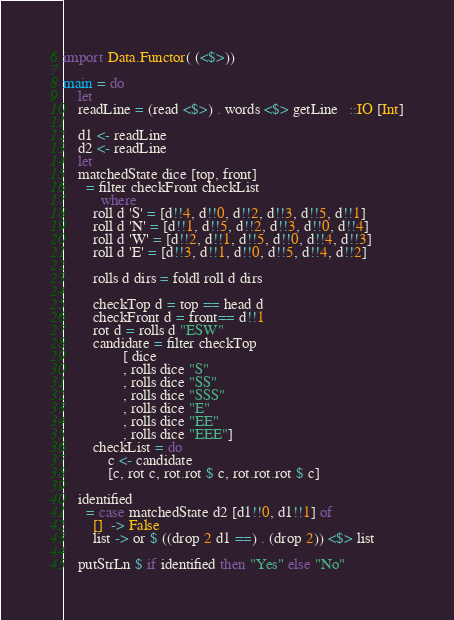<code> <loc_0><loc_0><loc_500><loc_500><_Haskell_>import Data.Functor( (<$>))

main = do
    let
	readLine = (read <$>) . words <$> getLine   ::IO [Int]

    d1 <- readLine
    d2 <- readLine
    let
	matchedState dice [top, front]
	  = filter checkFront checkList
	      where
		roll d 'S' = [d!!4, d!!0, d!!2, d!!3, d!!5, d!!1]
		roll d 'N' = [d!!1, d!!5, d!!2, d!!3, d!!0, d!!4]
		roll d 'W' = [d!!2, d!!1, d!!5, d!!0, d!!4, d!!3]
		roll d 'E' = [d!!3, d!!1, d!!0, d!!5, d!!4, d!!2]

		rolls d dirs = foldl roll d dirs

		checkTop d = top == head d
		checkFront d = front== d!!1
		rot d = rolls d "ESW"
		candidate = filter checkTop
				[ dice
				, rolls dice "S"
				, rolls dice "SS"
				, rolls dice "SSS"
				, rolls dice "E"
				, rolls dice "EE"
				, rolls dice "EEE"]
		checkList = do
		    c <- candidate
		    [c, rot c, rot.rot $ c, rot.rot.rot $ c]

	identified
	  = case matchedState d2 [d1!!0, d1!!1] of
		[]  -> False
		list -> or $ ((drop 2 d1 ==) . (drop 2)) <$> list

    putStrLn $ if identified then "Yes" else "No"

</code> 